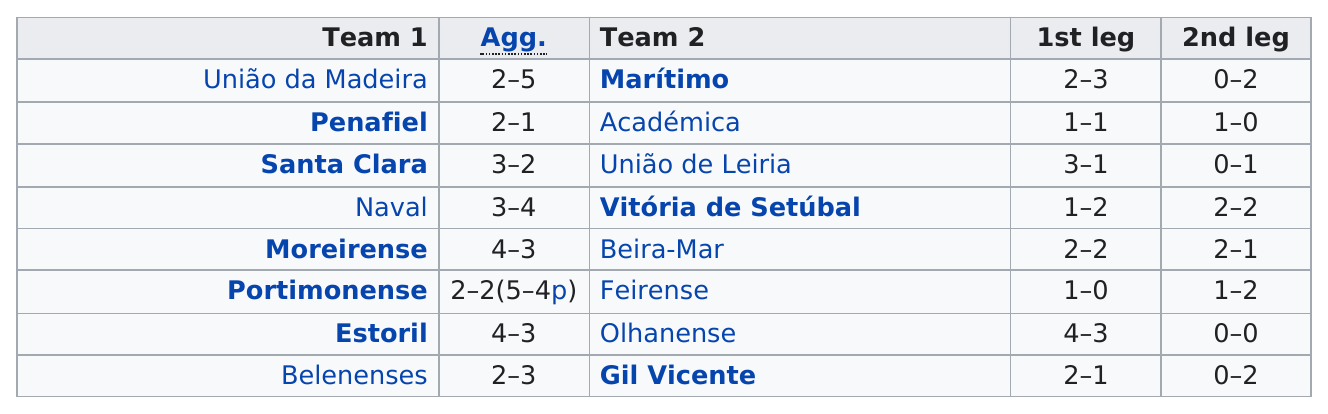Specify some key components in this picture. Vitória de Setúbal has the most letters of any winning team. In the second round, two ties occurred. The team that won after Santa Clara was Vitória de Setúbal. Vitoria de Setúbal emerged victorious in the recent naval match, having defeated União de Leiria in the previous game. What winning team has the least number of letters? Estoril has the fewest number of letters among all winning teams. 